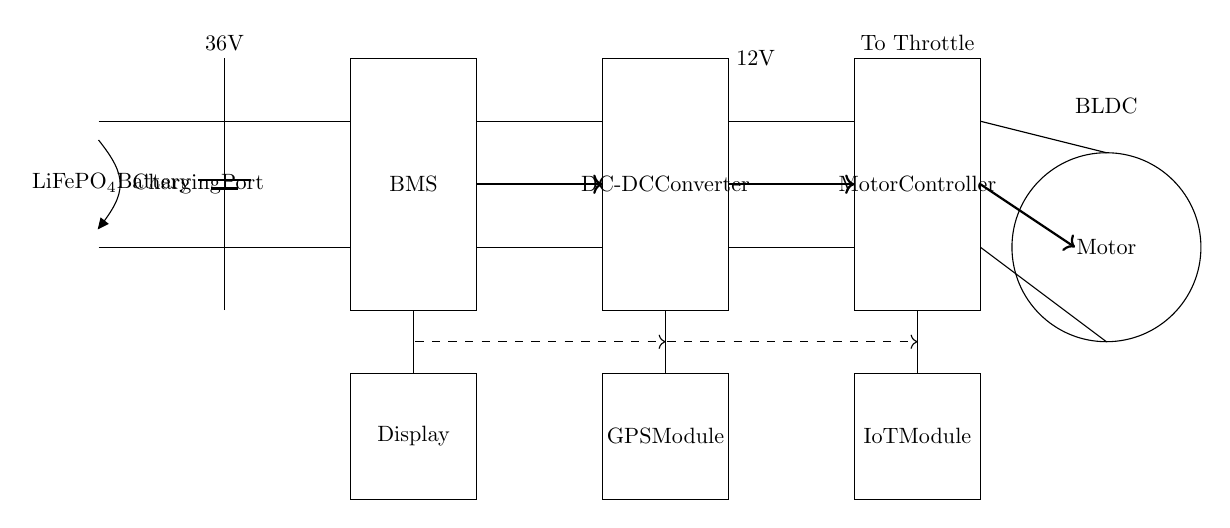What type of battery is used in this circuit? The circuit indicates that a lithium iron phosphate (LiFePO4) battery is used, which is denoted in the battery component label.
Answer: LiFePO4 What is the function of the BMS in this circuit? The BMS, or Battery Management System, is responsible for monitoring and managing the battery's state, including voltage, current, and temperature, ensuring safe operation.
Answer: Battery Management System What is the voltage output of the DC-DC converter? The DC-DC converter is designed to convert the voltage from the battery and provide a stable output of twelve volts as indicated in the label above it.
Answer: 12V What connects the GPS module to the rest of the circuit? The GPS module is connected through a control line, indicated by a dashed line leading directly to the IoT module, signifying communication between these components.
Answer: Control line How many components are involved in the power management circuit? The circuit includes five main components: the battery, BMS, DC-DC converter, motor controller, and motor, plus additional modules for GPS, IoT, and a display, totaling eight components.
Answer: Eight components What is supplied to the motor controller from the DC-DC converter? The motor controller receives a twelve-volt input from the DC-DC converter, as shown by the arrow directing power flow from the converter to the controller.
Answer: Twelve volts What acts as the primary load in this circuit? The primary load in this circuit is the motor, which is represented by the circular icon labeled "Motor," indicating where the power is ultimately delivered.
Answer: Motor 